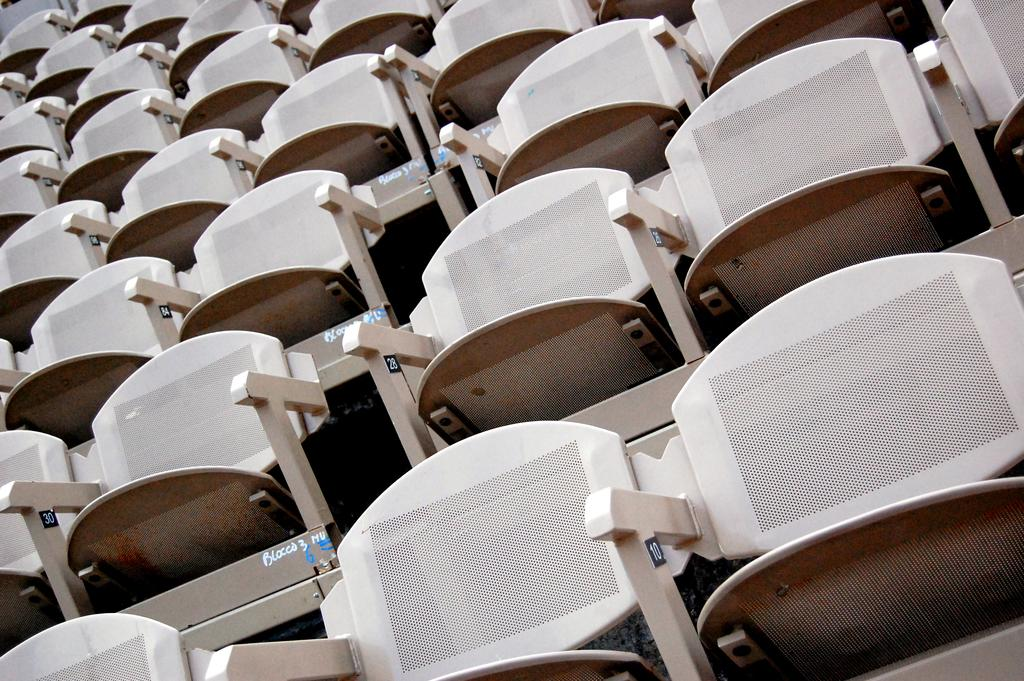What type of furniture is in the foreground of the image? There are chairs in the foreground of the image. What type of sail can be seen on the chairs in the image? There is no sail present on the chairs in the image. What season is depicted in the image? The provided facts do not give any information about the season depicted in the image. What type of vehicle is being driven in the image? There is no vehicle or driving activity present in the image. 